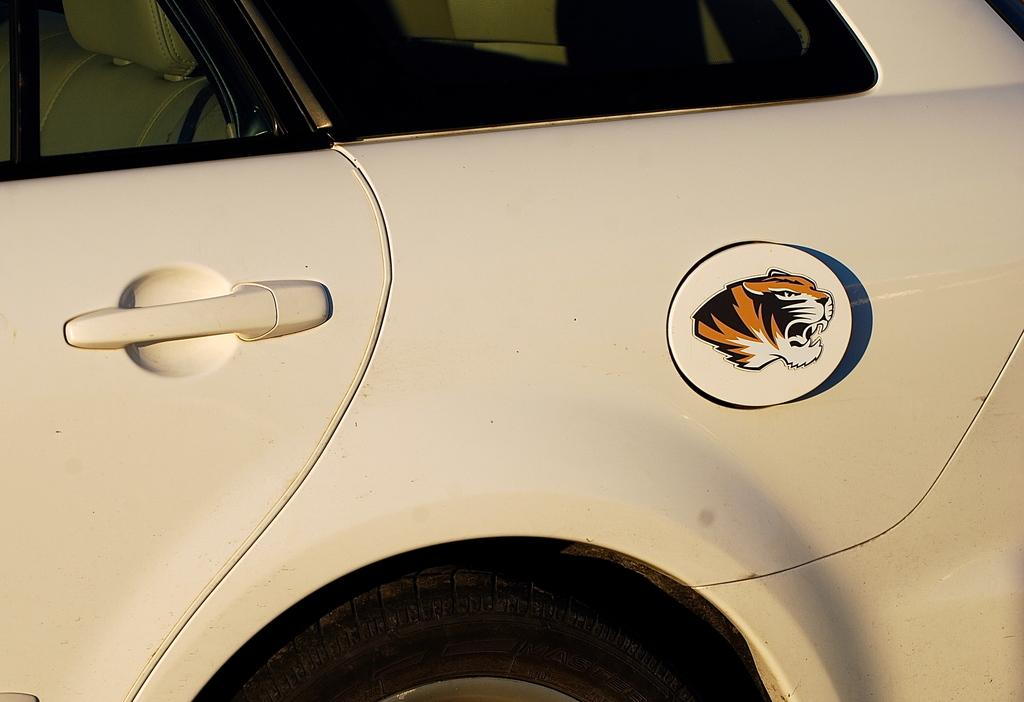What is the main subject of the image? There is a car in the image. Can you see the car smiling in the image? Cars do not have the ability to smile, so this cannot be observed in the image. 